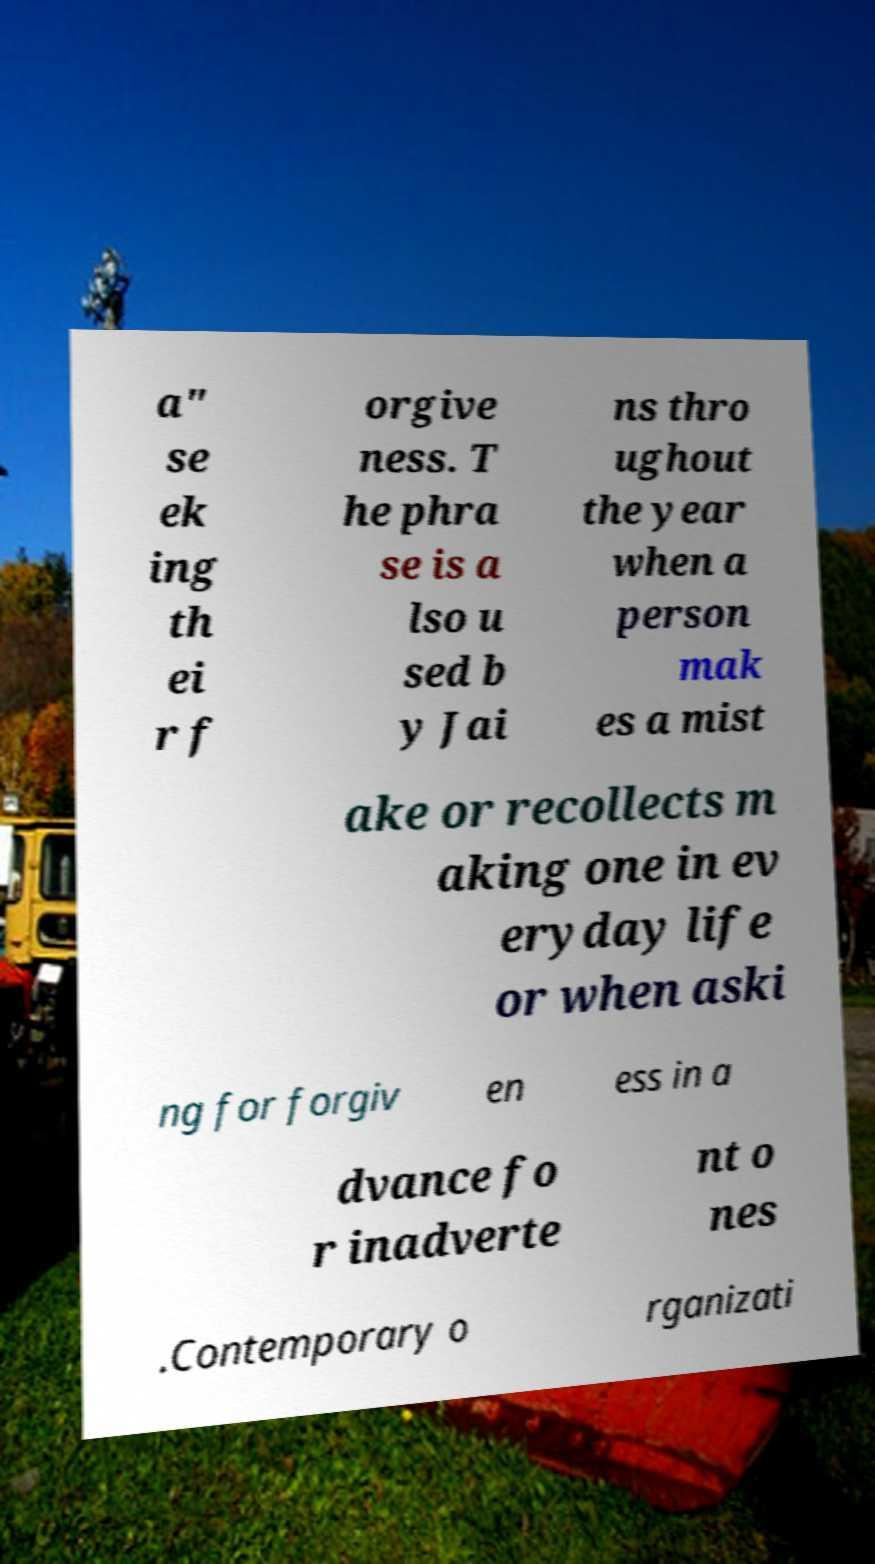Could you assist in decoding the text presented in this image and type it out clearly? a" se ek ing th ei r f orgive ness. T he phra se is a lso u sed b y Jai ns thro ughout the year when a person mak es a mist ake or recollects m aking one in ev eryday life or when aski ng for forgiv en ess in a dvance fo r inadverte nt o nes .Contemporary o rganizati 